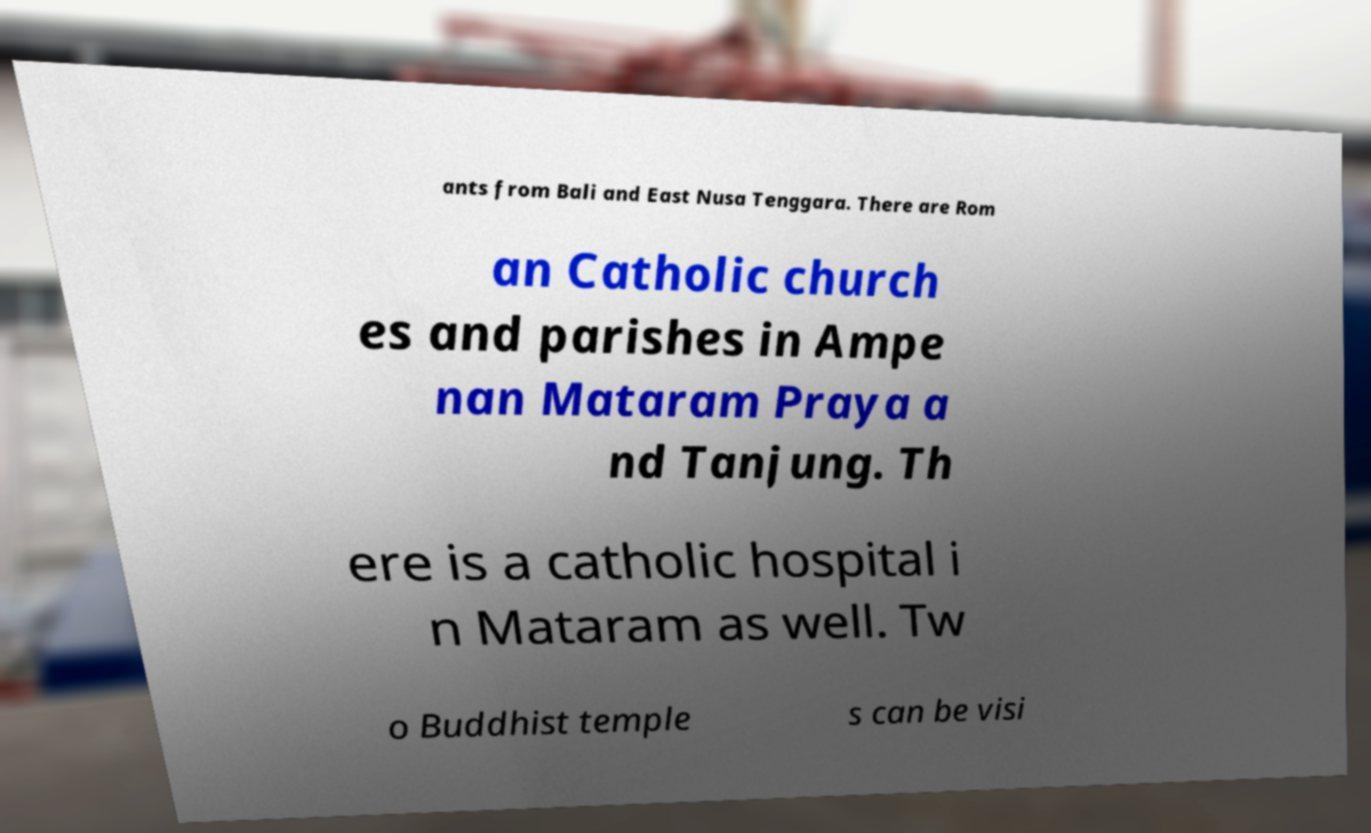Please identify and transcribe the text found in this image. ants from Bali and East Nusa Tenggara. There are Rom an Catholic church es and parishes in Ampe nan Mataram Praya a nd Tanjung. Th ere is a catholic hospital i n Mataram as well. Tw o Buddhist temple s can be visi 